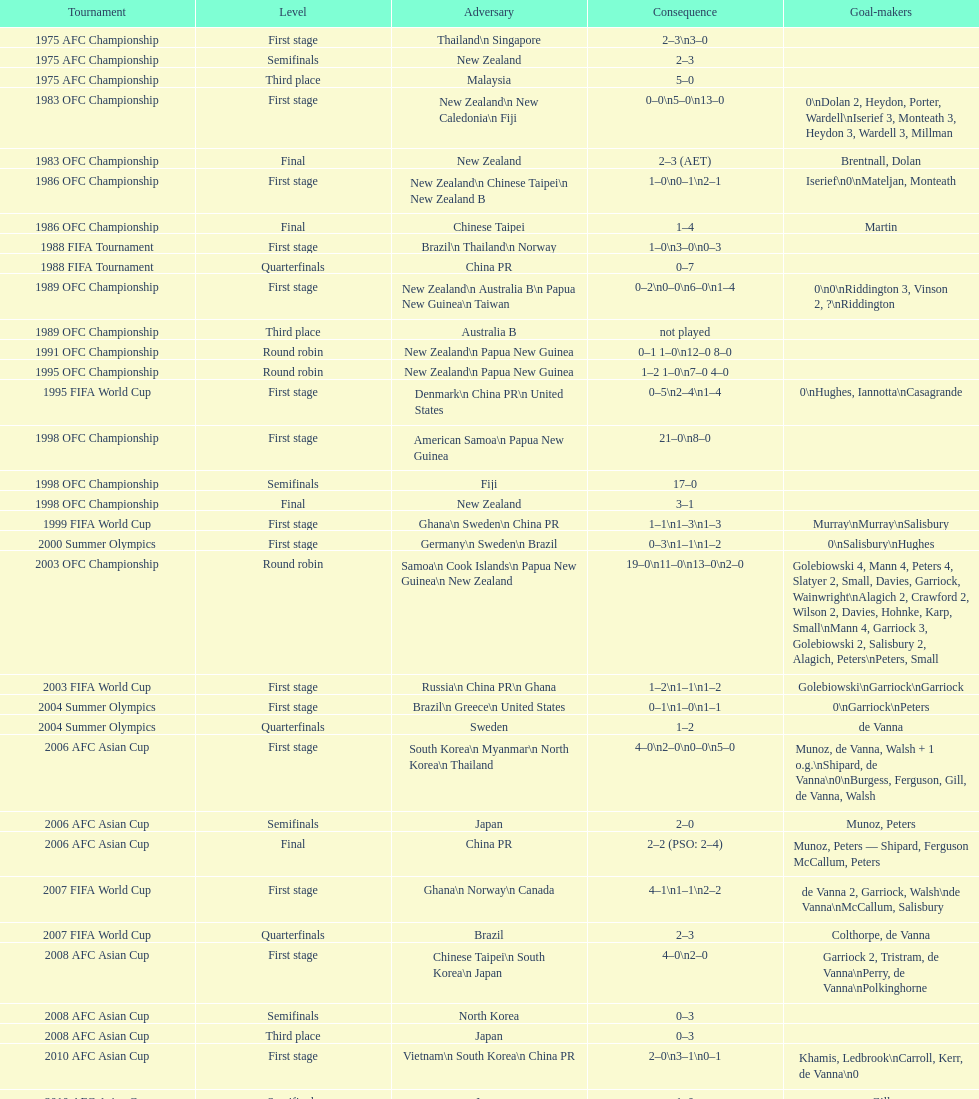What is the overall count of competitions? 21. 